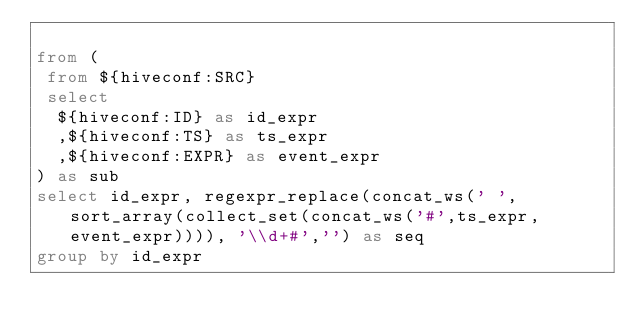<code> <loc_0><loc_0><loc_500><loc_500><_SQL_>
from (
 from ${hiveconf:SRC}
 select
  ${hiveconf:ID} as id_expr
  ,${hiveconf:TS} as ts_expr
  ,${hiveconf:EXPR} as event_expr
) as sub
select id_expr, regexpr_replace(concat_ws(' ',sort_array(collect_set(concat_ws('#',ts_expr, event_expr)))), '\\d+#','') as seq
group by id_expr
</code> 